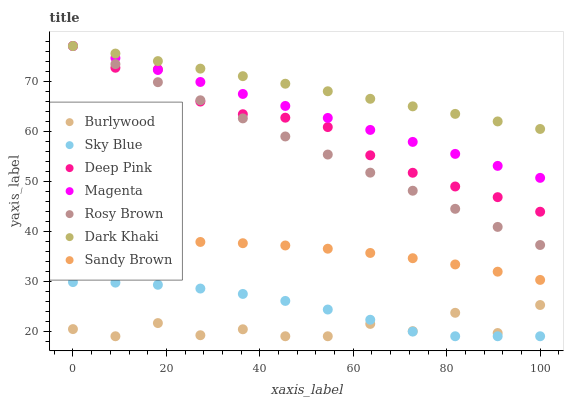Does Burlywood have the minimum area under the curve?
Answer yes or no. Yes. Does Dark Khaki have the maximum area under the curve?
Answer yes or no. Yes. Does Rosy Brown have the minimum area under the curve?
Answer yes or no. No. Does Rosy Brown have the maximum area under the curve?
Answer yes or no. No. Is Rosy Brown the smoothest?
Answer yes or no. Yes. Is Burlywood the roughest?
Answer yes or no. Yes. Is Burlywood the smoothest?
Answer yes or no. No. Is Rosy Brown the roughest?
Answer yes or no. No. Does Burlywood have the lowest value?
Answer yes or no. Yes. Does Rosy Brown have the lowest value?
Answer yes or no. No. Does Magenta have the highest value?
Answer yes or no. Yes. Does Burlywood have the highest value?
Answer yes or no. No. Is Sky Blue less than Magenta?
Answer yes or no. Yes. Is Rosy Brown greater than Sky Blue?
Answer yes or no. Yes. Does Deep Pink intersect Rosy Brown?
Answer yes or no. Yes. Is Deep Pink less than Rosy Brown?
Answer yes or no. No. Is Deep Pink greater than Rosy Brown?
Answer yes or no. No. Does Sky Blue intersect Magenta?
Answer yes or no. No. 